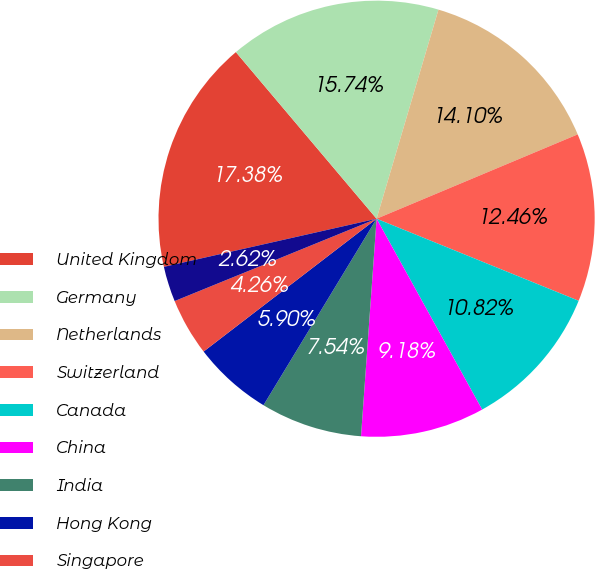Convert chart. <chart><loc_0><loc_0><loc_500><loc_500><pie_chart><fcel>United Kingdom<fcel>Germany<fcel>Netherlands<fcel>Switzerland<fcel>Canada<fcel>China<fcel>India<fcel>Hong Kong<fcel>Singapore<fcel>Sweden<nl><fcel>17.38%<fcel>15.74%<fcel>14.1%<fcel>12.46%<fcel>10.82%<fcel>9.18%<fcel>7.54%<fcel>5.9%<fcel>4.26%<fcel>2.62%<nl></chart> 